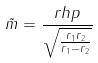<formula> <loc_0><loc_0><loc_500><loc_500>\tilde { m } = \frac { r h p } { \sqrt { \frac { r _ { 1 } r _ { 2 } } { r _ { 1 } - r _ { 2 } } } }</formula> 